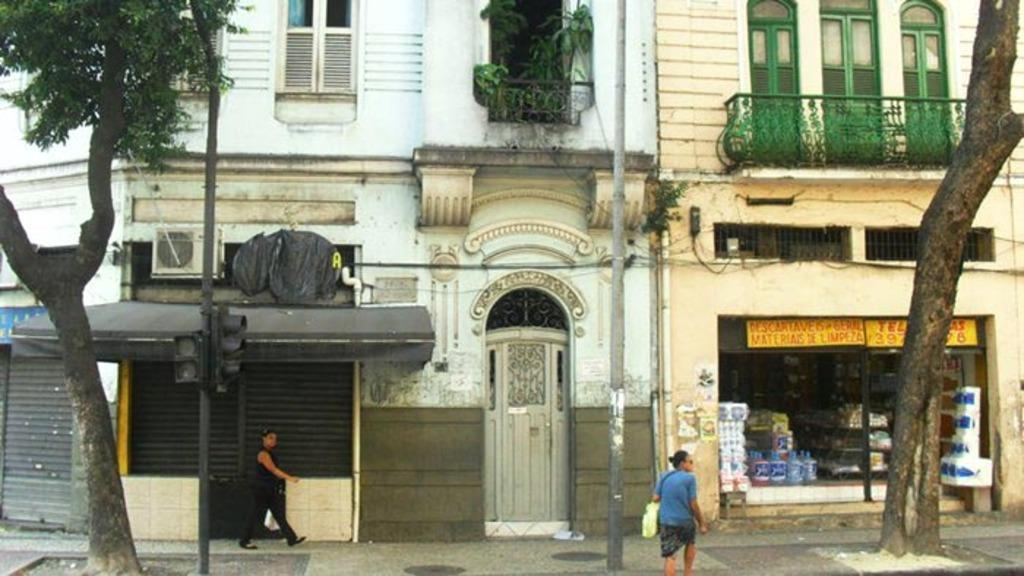What type of structure is in the image? There is a building in the image. What devices are present to provide cooling? Air conditioners are present in the image. What safety feature can be seen in the image? Railings are visible in the image. What type of vegetation is in the image? There are trees in the image. What type of establishment is in the image? There is a store in the image. What signage is present in the image? Name boards are present in the image. What infrastructure is visible in the image? Pipelines are visible in the image. What items can be found inside the store? Goods are present in the store. What activity is taking place in the image? Persons are walking on the road in the image. How many police officers are visible in the image? There are no police officers present in the image. What type of fruit is hanging from the air conditioners in the image? There is no fruit hanging from the air conditioners in the image. 